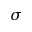<formula> <loc_0><loc_0><loc_500><loc_500>\sigma</formula> 